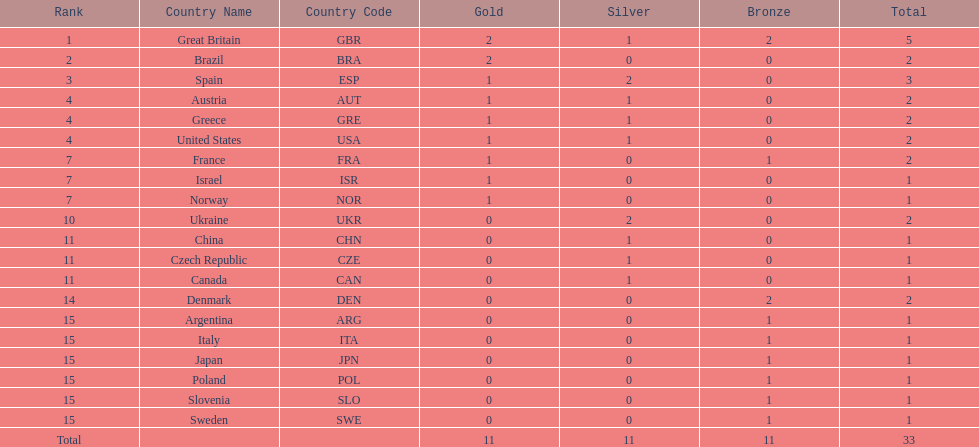What was the number of silver medals won by ukraine? 2. 